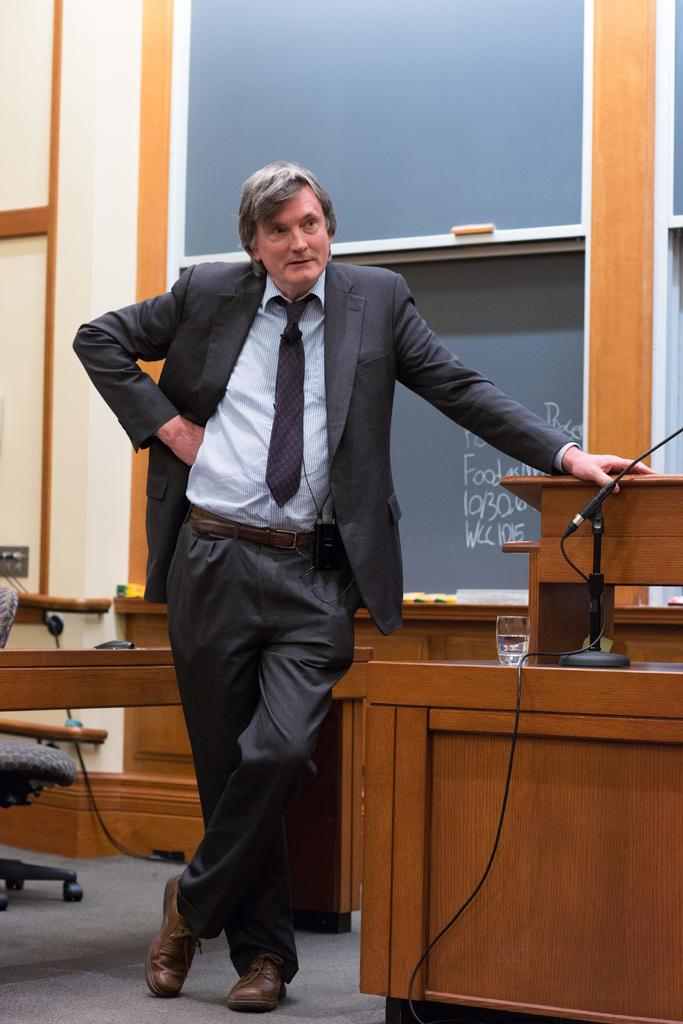What is the position of the man in the image? The man is standing on the left side in the image. What object is present near the man? There is a microphone in the image. What structure can be seen in the image? There is a podium in the image. What can be seen in the background of the image? There is a board visible in the background. What type of tub is visible in the image? There is no tub present in the image. What part of the man's body is missing in the image? The image shows the man's entire body, so no part is missing. 